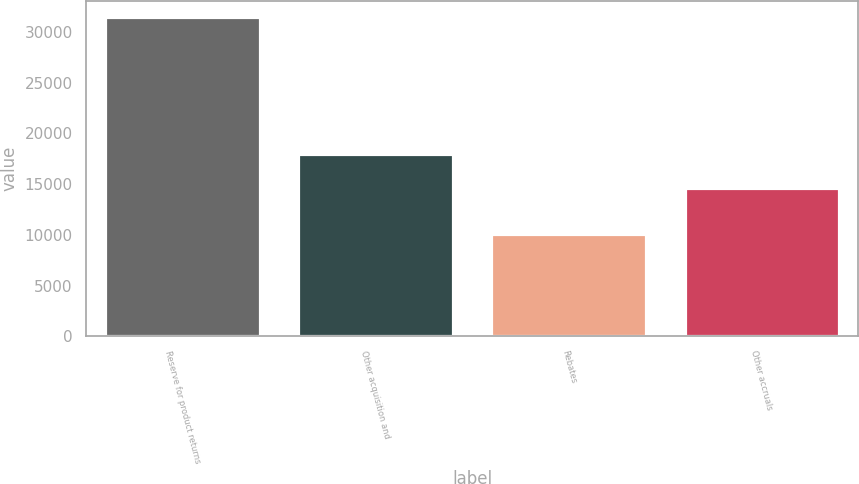Convert chart to OTSL. <chart><loc_0><loc_0><loc_500><loc_500><bar_chart><fcel>Reserve for product returns<fcel>Other acquisition and<fcel>Rebates<fcel>Other accruals<nl><fcel>31510<fcel>18001<fcel>10130<fcel>14602<nl></chart> 